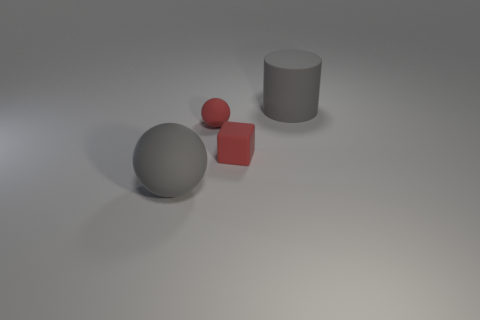Subtract all purple cylinders. Subtract all cyan cubes. How many cylinders are left? 1 Add 3 big gray things. How many objects exist? 7 Subtract all cylinders. How many objects are left? 3 Add 4 large gray cylinders. How many large gray cylinders exist? 5 Subtract 0 cyan cubes. How many objects are left? 4 Subtract all small red balls. Subtract all red spheres. How many objects are left? 2 Add 2 tiny red matte balls. How many tiny red matte balls are left? 3 